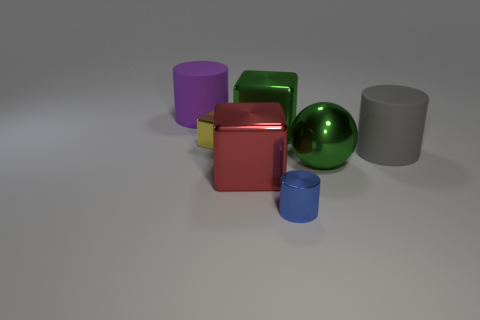Are there fewer blue cylinders than small brown metal objects?
Provide a succinct answer. No. Do the big block that is behind the green sphere and the big shiny ball have the same color?
Give a very brief answer. Yes. There is a big block in front of the small object that is behind the large matte cylinder that is in front of the small yellow metallic object; what is its material?
Offer a terse response. Metal. Are there any other spheres of the same color as the ball?
Offer a terse response. No. Are there fewer red cubes that are on the left side of the tiny shiny cube than shiny things?
Give a very brief answer. Yes. Do the green ball to the right of the purple cylinder and the blue object have the same size?
Provide a succinct answer. No. What number of big objects are to the right of the yellow shiny object and left of the gray thing?
Offer a terse response. 3. What size is the rubber object in front of the big matte cylinder on the left side of the yellow block?
Your response must be concise. Large. Is the number of yellow objects that are on the right side of the blue metallic thing less than the number of big green objects in front of the gray rubber cylinder?
Offer a very short reply. Yes. Does the tiny thing in front of the small yellow block have the same color as the large object that is left of the tiny yellow cube?
Offer a very short reply. No. 